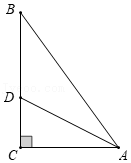Can you explain why AD being the bisector ensures that CD is perpendicular to AC? AD bisecting angle BAC implies it divides the angle into two equal parts. In a right triangle, if a line bisects the angle opposite the right angle, it also creates two smaller triangles that are similar to the original triangle and to each other. This geometric property ensures that line segments dropped perpendicularly from the bisector to the hypotenuse (like CD to AC) will indeed be perpendicular, adhering to these conditions of symmetry and similarity. 